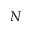<formula> <loc_0><loc_0><loc_500><loc_500>N</formula> 